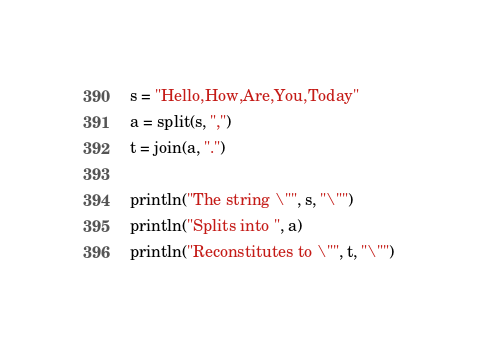<code> <loc_0><loc_0><loc_500><loc_500><_Julia_>s = "Hello,How,Are,You,Today"
a = split(s, ",")
t = join(a, ".")

println("The string \"", s, "\"")
println("Splits into ", a)
println("Reconstitutes to \"", t, "\"")
</code> 